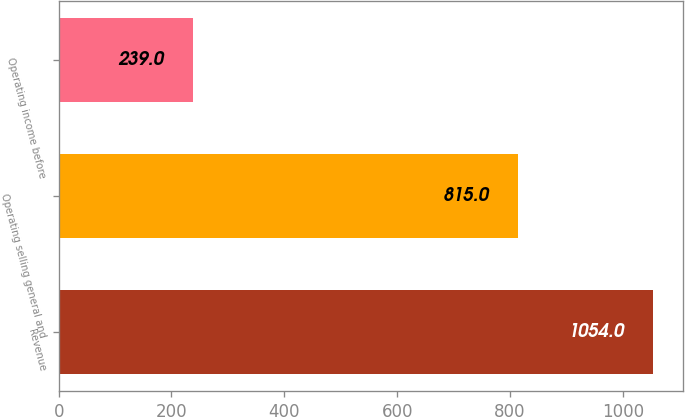Convert chart to OTSL. <chart><loc_0><loc_0><loc_500><loc_500><bar_chart><fcel>Revenue<fcel>Operating selling general and<fcel>Operating income before<nl><fcel>1054<fcel>815<fcel>239<nl></chart> 